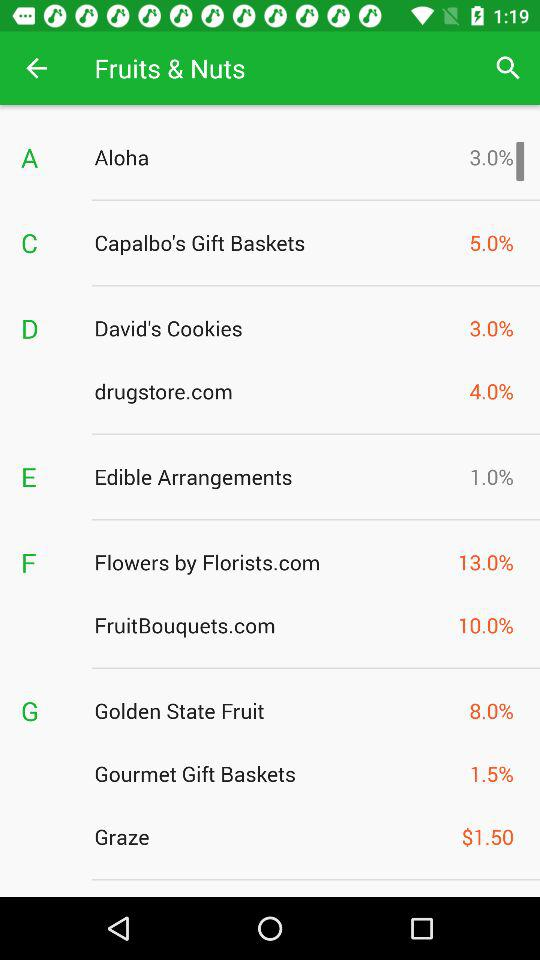What is the price of Graze? The price is $1.50. 